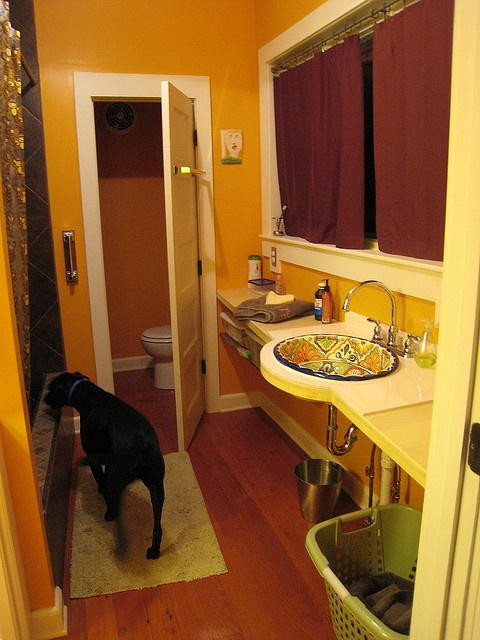Describe the objects in this image and their specific colors. I can see dog in lightpink, black, maroon, olive, and brown tones, sink in lightpink, orange, khaki, olive, and tan tones, cup in lightpink, black, maroon, and olive tones, toilet in lightpink, brown, maroon, and gray tones, and bottle in lightpink, gold, tan, and olive tones in this image. 